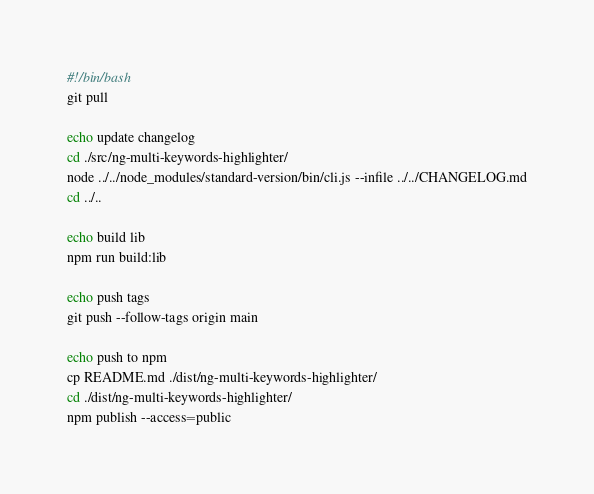<code> <loc_0><loc_0><loc_500><loc_500><_Bash_>#!/bin/bash
git pull

echo update changelog
cd ./src/ng-multi-keywords-highlighter/
node ../../node_modules/standard-version/bin/cli.js --infile ../../CHANGELOG.md
cd ../..

echo build lib
npm run build:lib

echo push tags
git push --follow-tags origin main

echo push to npm
cp README.md ./dist/ng-multi-keywords-highlighter/
cd ./dist/ng-multi-keywords-highlighter/
npm publish --access=public
</code> 